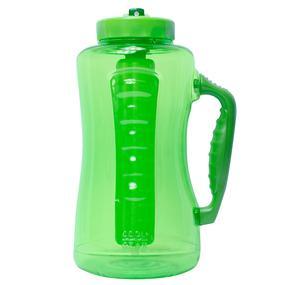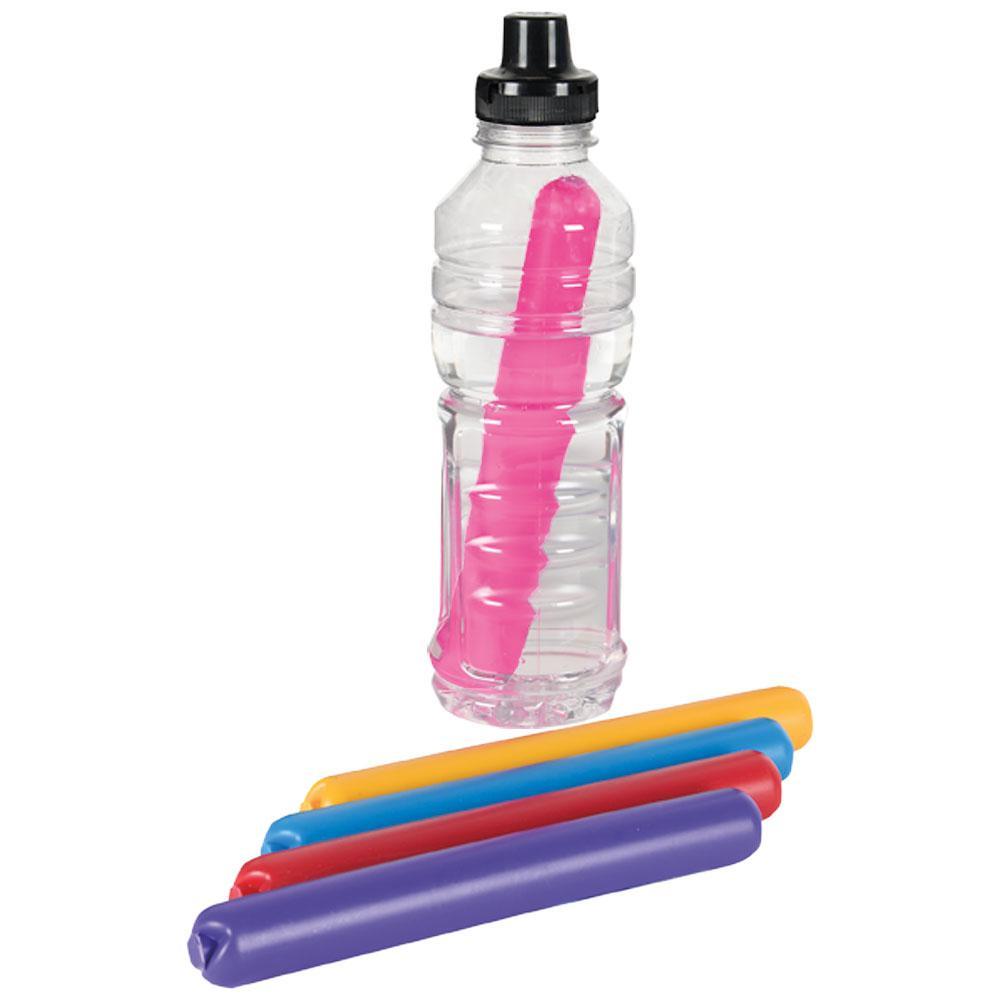The first image is the image on the left, the second image is the image on the right. Assess this claim about the two images: "An image shows some type of freezing sticks next to a water bottle.". Correct or not? Answer yes or no. Yes. 